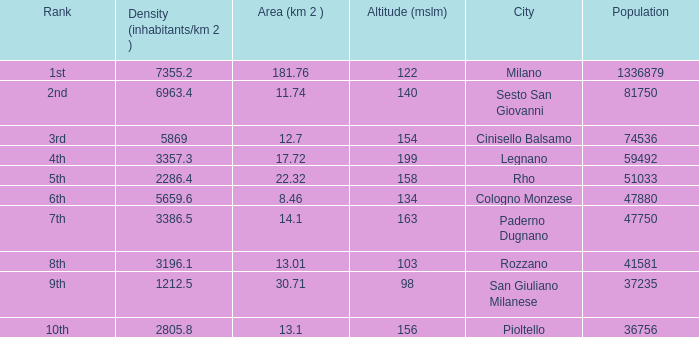Which Population is the highest one that has a Density (inhabitants/km 2) larger than 2805.8, and a Rank of 1st, and an Altitude (mslm) smaller than 122? None. 